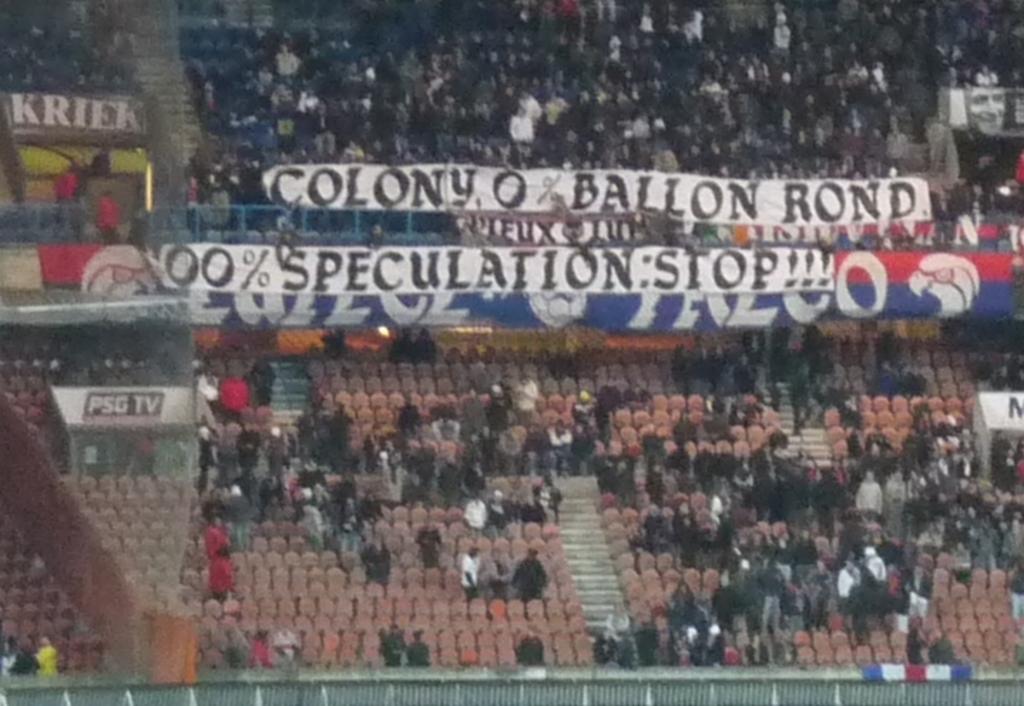What tv station is mentioned on the left?
Keep it short and to the point. Psg tv. 